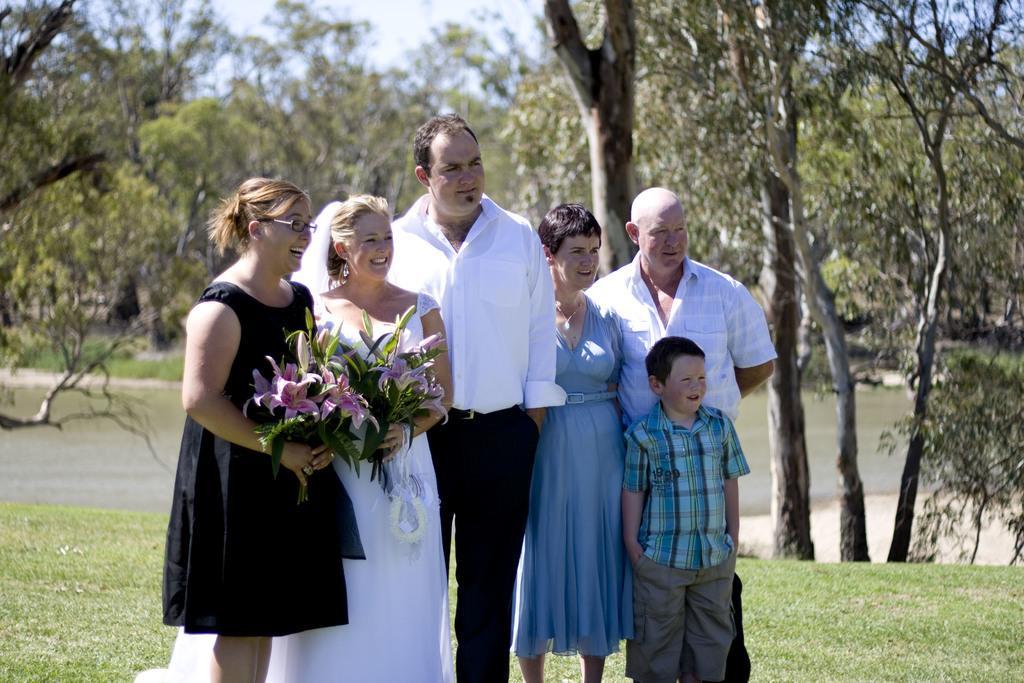Could you give a brief overview of what you see in this image? This is an outside view. Here I can see few people are standing and smiling by looking at the right side. In the background there is a lake. I can see the grass on the ground. In the background there are many trees. 